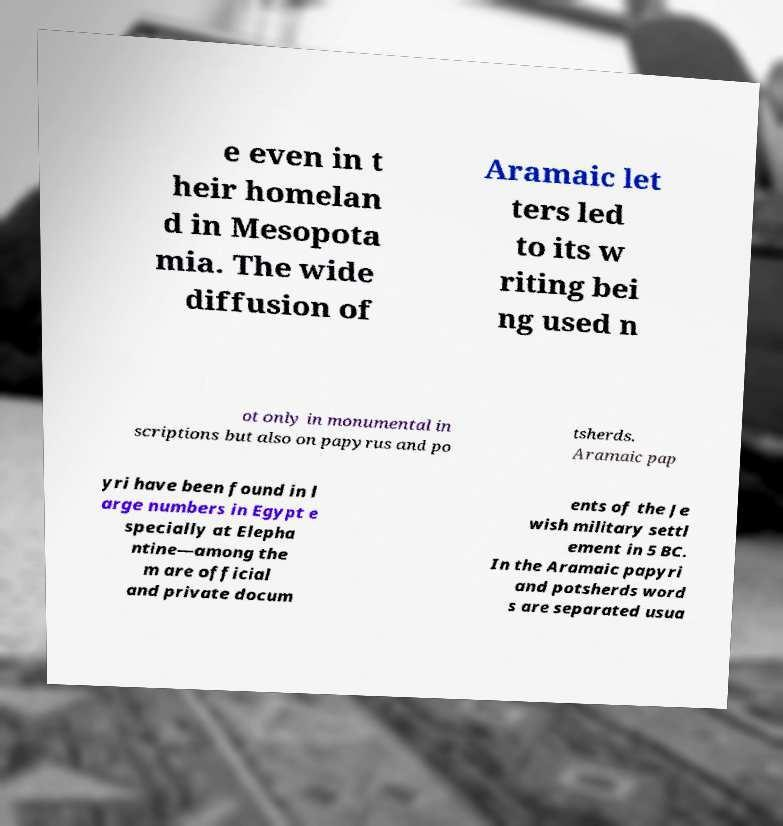Could you assist in decoding the text presented in this image and type it out clearly? e even in t heir homelan d in Mesopota mia. The wide diffusion of Aramaic let ters led to its w riting bei ng used n ot only in monumental in scriptions but also on papyrus and po tsherds. Aramaic pap yri have been found in l arge numbers in Egypt e specially at Elepha ntine—among the m are official and private docum ents of the Je wish military settl ement in 5 BC. In the Aramaic papyri and potsherds word s are separated usua 